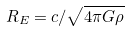Convert formula to latex. <formula><loc_0><loc_0><loc_500><loc_500>R _ { E } = c / \sqrt { 4 \pi G \rho }</formula> 